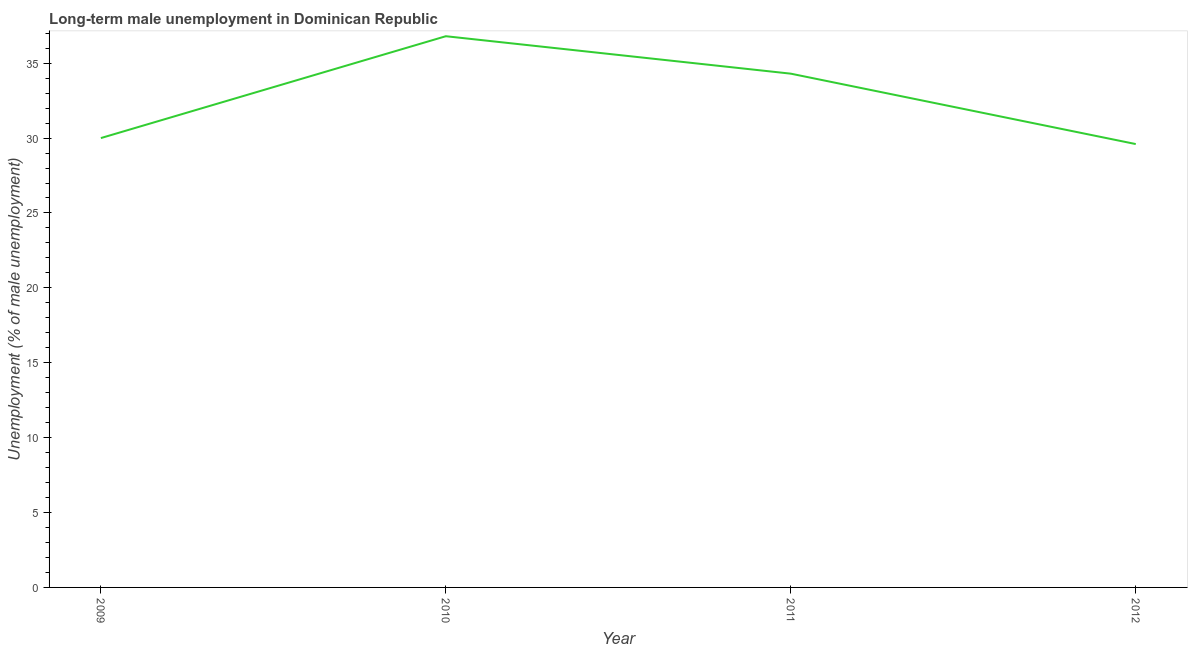What is the long-term male unemployment in 2011?
Your answer should be compact. 34.3. Across all years, what is the maximum long-term male unemployment?
Your answer should be very brief. 36.8. Across all years, what is the minimum long-term male unemployment?
Offer a very short reply. 29.6. What is the sum of the long-term male unemployment?
Provide a short and direct response. 130.7. What is the average long-term male unemployment per year?
Keep it short and to the point. 32.67. What is the median long-term male unemployment?
Give a very brief answer. 32.15. In how many years, is the long-term male unemployment greater than 6 %?
Offer a very short reply. 4. Do a majority of the years between 2009 and 2011 (inclusive) have long-term male unemployment greater than 32 %?
Give a very brief answer. Yes. What is the ratio of the long-term male unemployment in 2011 to that in 2012?
Provide a succinct answer. 1.16. Is the difference between the long-term male unemployment in 2009 and 2012 greater than the difference between any two years?
Your answer should be very brief. No. What is the difference between the highest and the second highest long-term male unemployment?
Offer a very short reply. 2.5. What is the difference between the highest and the lowest long-term male unemployment?
Make the answer very short. 7.2. Does the long-term male unemployment monotonically increase over the years?
Provide a succinct answer. No. How many years are there in the graph?
Your answer should be very brief. 4. What is the title of the graph?
Your response must be concise. Long-term male unemployment in Dominican Republic. What is the label or title of the Y-axis?
Offer a very short reply. Unemployment (% of male unemployment). What is the Unemployment (% of male unemployment) in 2009?
Provide a succinct answer. 30. What is the Unemployment (% of male unemployment) in 2010?
Your response must be concise. 36.8. What is the Unemployment (% of male unemployment) of 2011?
Your answer should be very brief. 34.3. What is the Unemployment (% of male unemployment) of 2012?
Your answer should be compact. 29.6. What is the difference between the Unemployment (% of male unemployment) in 2009 and 2010?
Keep it short and to the point. -6.8. What is the difference between the Unemployment (% of male unemployment) in 2009 and 2012?
Provide a succinct answer. 0.4. What is the difference between the Unemployment (% of male unemployment) in 2010 and 2011?
Offer a very short reply. 2.5. What is the difference between the Unemployment (% of male unemployment) in 2011 and 2012?
Give a very brief answer. 4.7. What is the ratio of the Unemployment (% of male unemployment) in 2009 to that in 2010?
Offer a terse response. 0.81. What is the ratio of the Unemployment (% of male unemployment) in 2009 to that in 2012?
Give a very brief answer. 1.01. What is the ratio of the Unemployment (% of male unemployment) in 2010 to that in 2011?
Offer a terse response. 1.07. What is the ratio of the Unemployment (% of male unemployment) in 2010 to that in 2012?
Offer a terse response. 1.24. What is the ratio of the Unemployment (% of male unemployment) in 2011 to that in 2012?
Offer a very short reply. 1.16. 